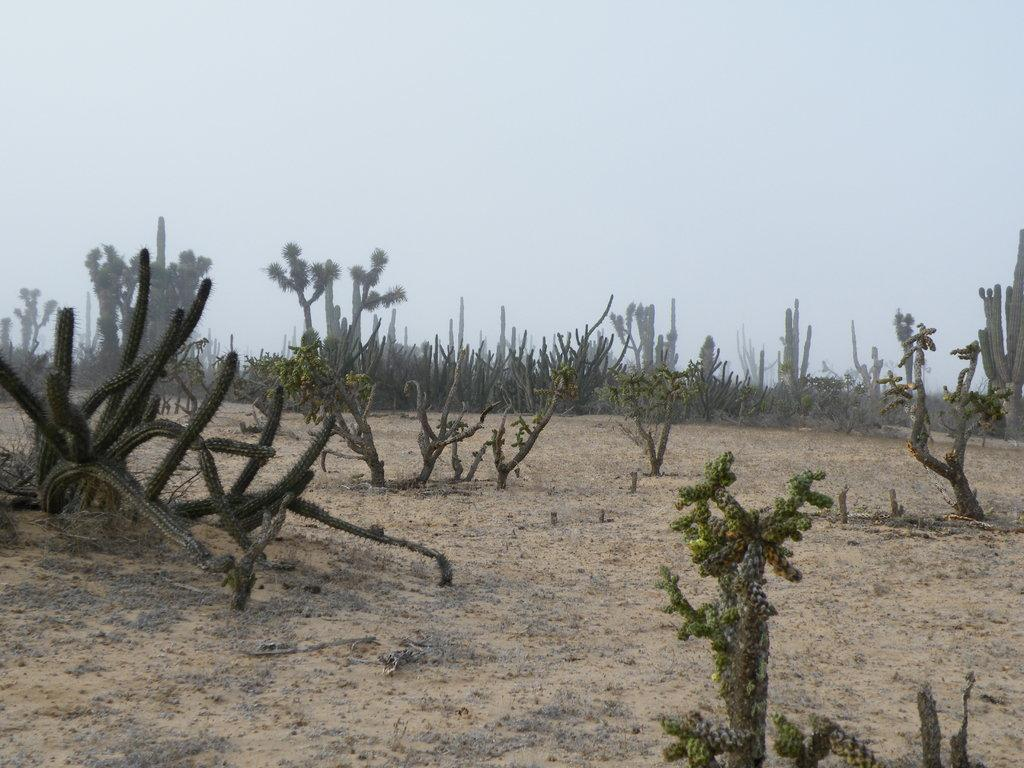What type of plants can be seen on the ground in the image? There are cactus on the ground in the image. What other types of plants are present in the image? There are plants in the image. What is visible at the top of the image? The sky is visible at the top of the image. What type of beef is being served by the band in the image? There is no beef or band present in the image; it features cactus and plants on the ground with the sky visible at the top. 